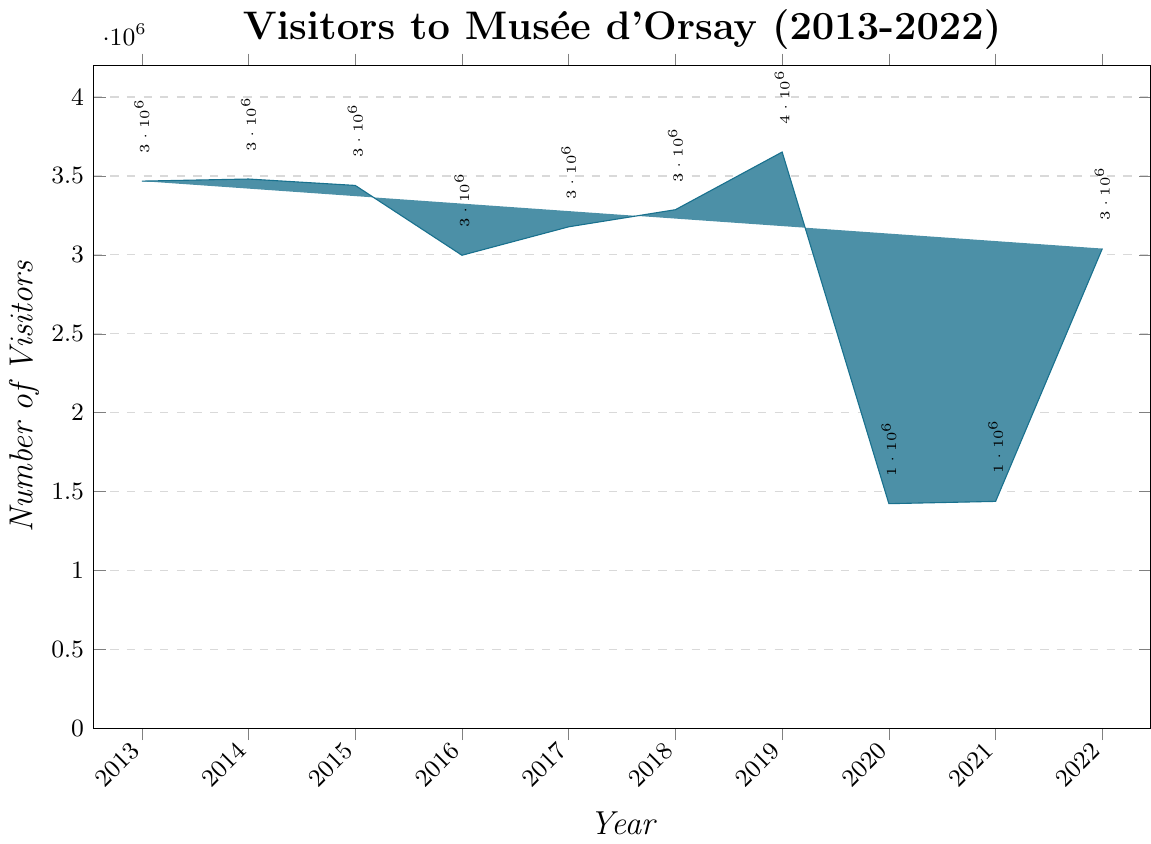What's the total number of visitors across all years? To find the total number of visitors across all years, sum the values for each year: 3467320 + 3480609 + 3440000 + 2997622 + 3177842 + 3286224 + 3651616 + 1423545 + 1438060 + 3039972 = 29543810
Answer: 29543810 How did the number of visitors in 2020 compare to the previous year, 2019? Refer to the values for 2019 and 2020 in the chart. The number of visitors in 2019 is 3651616 and in 2020 it is 1423545. The difference is 3651616 - 1423545, indicating a significant drop in visitors in 2020.
Answer: The number of visitors dropped by 2228071 from 2019 to 2020 Which year had the highest number of visitors, and what was the number? Identify the tallest bar on the chart, which corresponds to the year 2019. The height (value) of this bar is 3651616.
Answer: 2019 with 3651616 visitors What are the average visitors per year over the decade? To find the average, sum all the visitors from each year and divide by the number of years (10). Total visitors = 29543810; Average = 29543810 / 10 = 2954381
Answer: 2954381 How did the visitors in 2018 compare to those in 2017? The number of visitors in 2018 is 3286224 and in 2017 it is 3177842. By comparing these values, 3286224 - 3177842, we find an increase of 108382 visitors in 2018.
Answer: The visitors increased by 108382 in 2018 compared to 2017 Which years had fewer than 1500000 visitors? Identify the bars whose heights correspond to fewer than 1500000 visitors. The years are 2020 (1423545) and 2021 (1438060).
Answer: 2020 and 2021 What is the median number of visitors over these years? To find the median, list all values in ascending order and locate the middle value. Values: 1423545, 1438060, 2997622, 3039972, 3177842, 3286224, 3440000, 3467320, 3480609, 3651616. The middle value (average of 5th and 6th values) is (3177842 + 3286224) / 2 = 3232033.
Answer: 3232033 How does the number of visitors in 2022 compare to the number in 2016? The number of visitors in 2022 is 3039972, and in 2016 it is 2997622. Compare these values, 3039972 - 2997622 = 42350, showing more visitors in 2022.
Answer: The visitors in 2022 were 42350 more than in 2016 Which year had the lowest number of visitors? Identify the shortest bar on the chart, which corresponds to the year 2020 with 1423545 visitors.
Answer: 2020 What was the difference in visitors between the years 2015 and 2017? Subtract the number of visitors in 2017 from the number in 2015: 3440000 - 3177842 = 262158.
Answer: 262158 